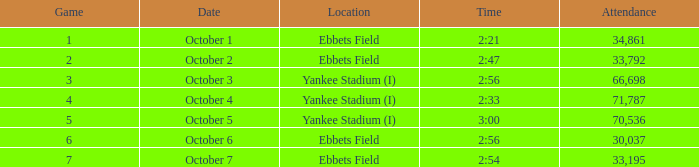Where is ebbets field situated, and at 2:56, and a match greater than 6 has what total attendance? None. Can you parse all the data within this table? {'header': ['Game', 'Date', 'Location', 'Time', 'Attendance'], 'rows': [['1', 'October 1', 'Ebbets Field', '2:21', '34,861'], ['2', 'October 2', 'Ebbets Field', '2:47', '33,792'], ['3', 'October 3', 'Yankee Stadium (I)', '2:56', '66,698'], ['4', 'October 4', 'Yankee Stadium (I)', '2:33', '71,787'], ['5', 'October 5', 'Yankee Stadium (I)', '3:00', '70,536'], ['6', 'October 6', 'Ebbets Field', '2:56', '30,037'], ['7', 'October 7', 'Ebbets Field', '2:54', '33,195']]} 